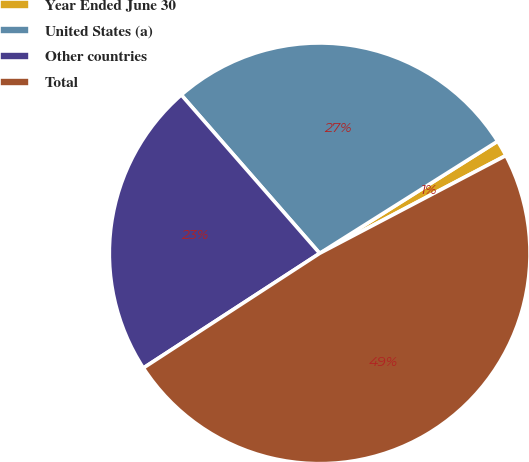Convert chart. <chart><loc_0><loc_0><loc_500><loc_500><pie_chart><fcel>Year Ended June 30<fcel>United States (a)<fcel>Other countries<fcel>Total<nl><fcel>1.25%<fcel>27.48%<fcel>22.75%<fcel>48.52%<nl></chart> 